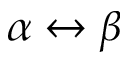<formula> <loc_0><loc_0><loc_500><loc_500>\alpha \leftrightarrow \beta</formula> 